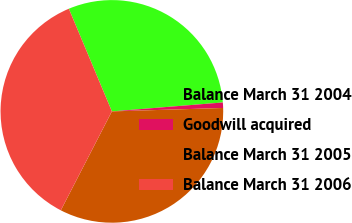Convert chart. <chart><loc_0><loc_0><loc_500><loc_500><pie_chart><fcel>Balance March 31 2004<fcel>Goodwill acquired<fcel>Balance March 31 2005<fcel>Balance March 31 2006<nl><fcel>30.04%<fcel>0.79%<fcel>33.07%<fcel>36.1%<nl></chart> 